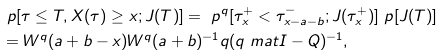<formula> <loc_0><loc_0><loc_500><loc_500>& \ p [ \tau \leq T , X ( \tau ) \geq x ; J ( T ) ] = \ p ^ { q } [ \tau _ { x } ^ { + } < \tau _ { x - a - b } ^ { - } ; J ( \tau _ { x } ^ { + } ) ] \ p [ J ( T ) ] \\ & = W ^ { q } ( a + b - x ) W ^ { q } ( a + b ) ^ { - 1 } q ( q \ m a t I - Q ) ^ { - 1 } ,</formula> 